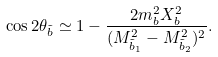<formula> <loc_0><loc_0><loc_500><loc_500>\cos 2 \theta _ { \tilde { b } } \simeq 1 - \frac { 2 m _ { b } ^ { 2 } X _ { b } ^ { 2 } } { ( M _ { \tilde { b } _ { 1 } } ^ { 2 } - M _ { \tilde { b } _ { 2 } } ^ { 2 } ) ^ { 2 } } .</formula> 